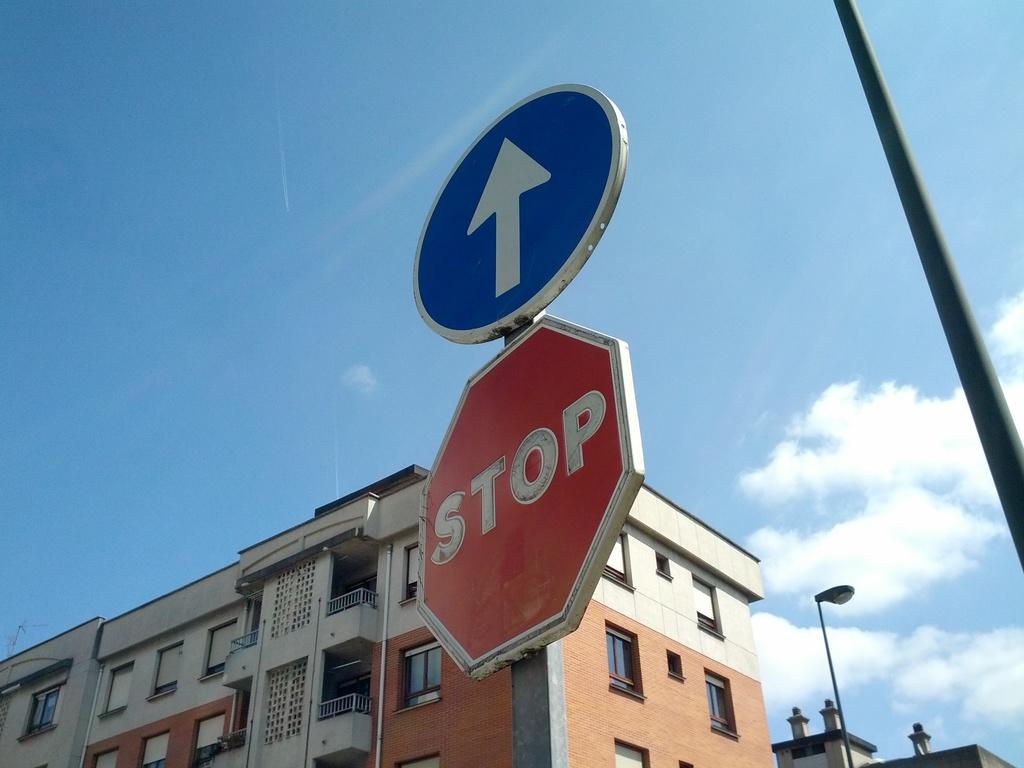What is the lower sign telling you what to do?
Make the answer very short. Stop. 